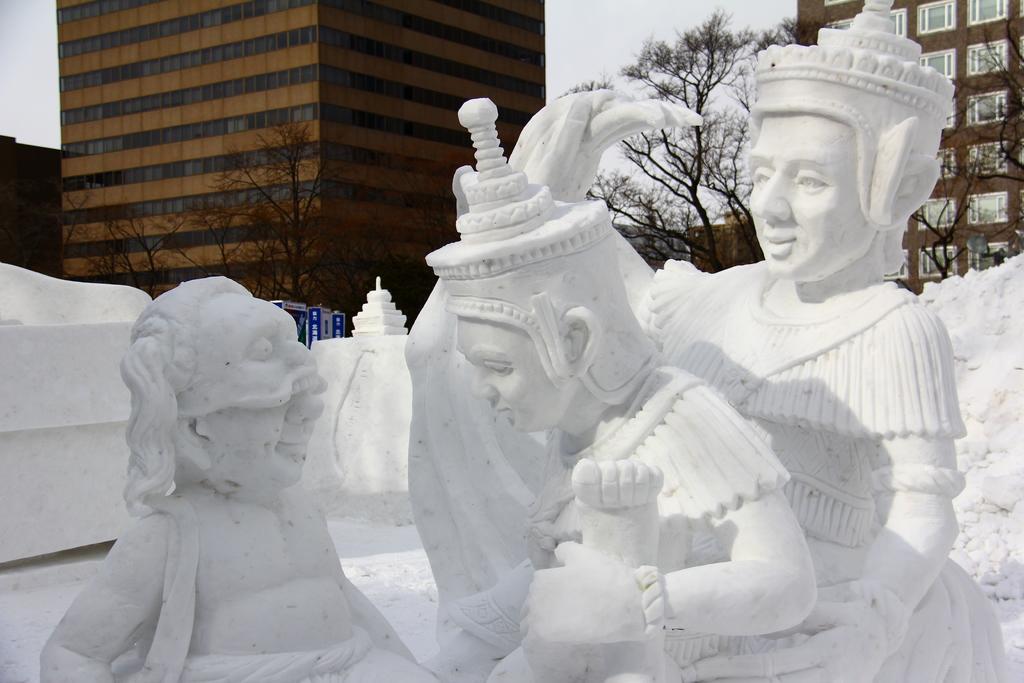How would you summarize this image in a sentence or two? In this picture there are sculptures in the foreground. At the back there are buildings and trees and there are boards on the pole. At the top there is sky. 